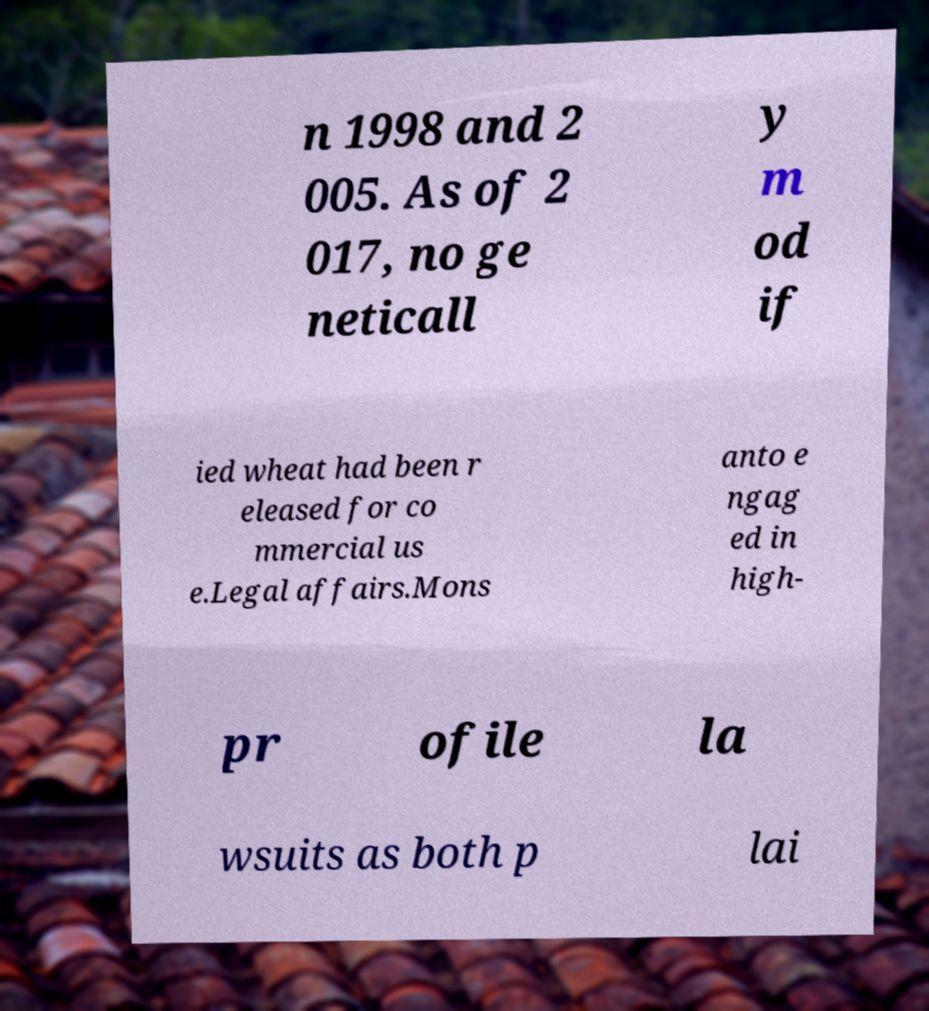Can you read and provide the text displayed in the image?This photo seems to have some interesting text. Can you extract and type it out for me? n 1998 and 2 005. As of 2 017, no ge neticall y m od if ied wheat had been r eleased for co mmercial us e.Legal affairs.Mons anto e ngag ed in high- pr ofile la wsuits as both p lai 